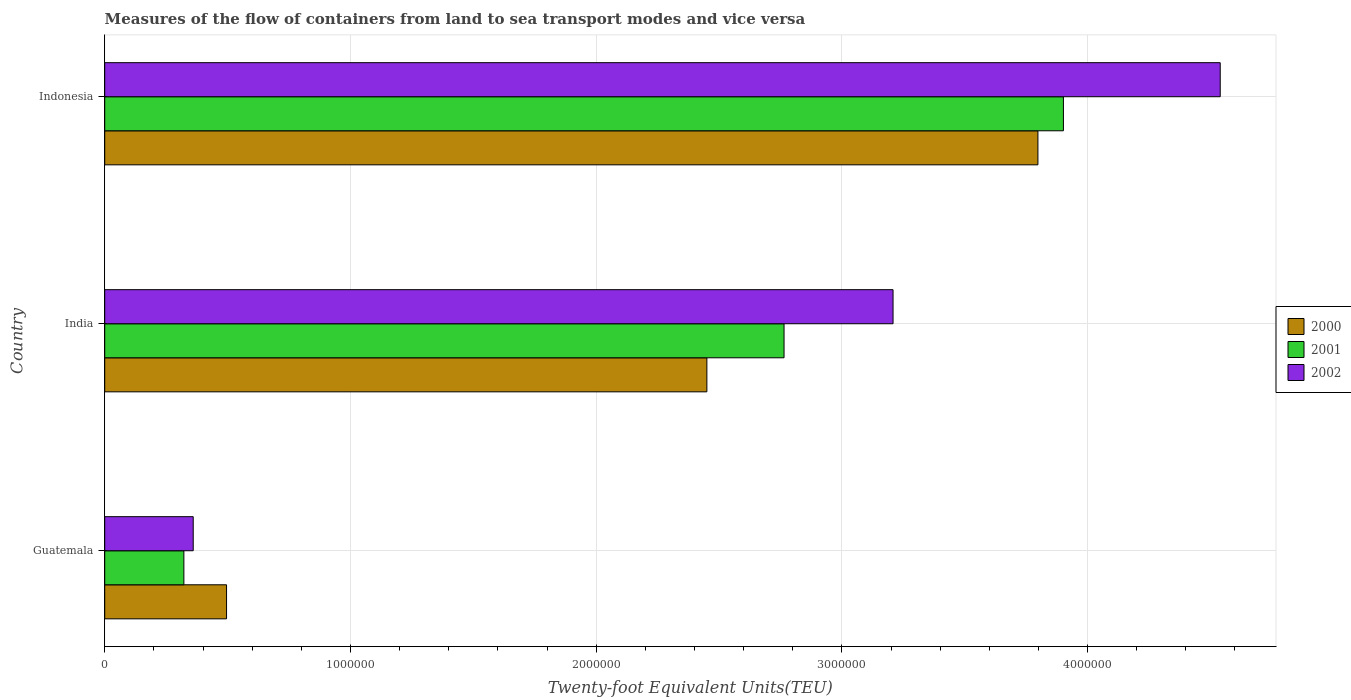Are the number of bars per tick equal to the number of legend labels?
Provide a succinct answer. Yes. Are the number of bars on each tick of the Y-axis equal?
Your answer should be very brief. Yes. How many bars are there on the 3rd tick from the bottom?
Provide a short and direct response. 3. What is the label of the 1st group of bars from the top?
Make the answer very short. Indonesia. What is the container port traffic in 2000 in India?
Your answer should be very brief. 2.45e+06. Across all countries, what is the maximum container port traffic in 2000?
Offer a very short reply. 3.80e+06. Across all countries, what is the minimum container port traffic in 2000?
Your answer should be very brief. 4.96e+05. In which country was the container port traffic in 2000 minimum?
Your response must be concise. Guatemala. What is the total container port traffic in 2001 in the graph?
Make the answer very short. 6.99e+06. What is the difference between the container port traffic in 2001 in India and that in Indonesia?
Provide a short and direct response. -1.14e+06. What is the difference between the container port traffic in 2001 in Guatemala and the container port traffic in 2000 in India?
Offer a very short reply. -2.13e+06. What is the average container port traffic in 2000 per country?
Offer a very short reply. 2.25e+06. What is the difference between the container port traffic in 2001 and container port traffic in 2000 in India?
Offer a very short reply. 3.14e+05. What is the ratio of the container port traffic in 2000 in Guatemala to that in Indonesia?
Your answer should be very brief. 0.13. Is the difference between the container port traffic in 2001 in India and Indonesia greater than the difference between the container port traffic in 2000 in India and Indonesia?
Offer a very short reply. Yes. What is the difference between the highest and the second highest container port traffic in 2002?
Your answer should be very brief. 1.33e+06. What is the difference between the highest and the lowest container port traffic in 2001?
Your response must be concise. 3.58e+06. In how many countries, is the container port traffic in 2000 greater than the average container port traffic in 2000 taken over all countries?
Offer a terse response. 2. Is the sum of the container port traffic in 2000 in India and Indonesia greater than the maximum container port traffic in 2001 across all countries?
Your answer should be compact. Yes. How many countries are there in the graph?
Keep it short and to the point. 3. What is the difference between two consecutive major ticks on the X-axis?
Ensure brevity in your answer.  1.00e+06. Are the values on the major ticks of X-axis written in scientific E-notation?
Keep it short and to the point. No. Does the graph contain any zero values?
Provide a short and direct response. No. Does the graph contain grids?
Your answer should be very brief. Yes. How are the legend labels stacked?
Your answer should be compact. Vertical. What is the title of the graph?
Offer a very short reply. Measures of the flow of containers from land to sea transport modes and vice versa. Does "1969" appear as one of the legend labels in the graph?
Give a very brief answer. No. What is the label or title of the X-axis?
Offer a very short reply. Twenty-foot Equivalent Units(TEU). What is the Twenty-foot Equivalent Units(TEU) of 2000 in Guatemala?
Keep it short and to the point. 4.96e+05. What is the Twenty-foot Equivalent Units(TEU) of 2001 in Guatemala?
Offer a very short reply. 3.22e+05. What is the Twenty-foot Equivalent Units(TEU) in 2002 in Guatemala?
Your response must be concise. 3.60e+05. What is the Twenty-foot Equivalent Units(TEU) of 2000 in India?
Make the answer very short. 2.45e+06. What is the Twenty-foot Equivalent Units(TEU) in 2001 in India?
Offer a very short reply. 2.76e+06. What is the Twenty-foot Equivalent Units(TEU) in 2002 in India?
Your answer should be compact. 3.21e+06. What is the Twenty-foot Equivalent Units(TEU) of 2000 in Indonesia?
Offer a terse response. 3.80e+06. What is the Twenty-foot Equivalent Units(TEU) in 2001 in Indonesia?
Give a very brief answer. 3.90e+06. What is the Twenty-foot Equivalent Units(TEU) of 2002 in Indonesia?
Provide a short and direct response. 4.54e+06. Across all countries, what is the maximum Twenty-foot Equivalent Units(TEU) of 2000?
Ensure brevity in your answer.  3.80e+06. Across all countries, what is the maximum Twenty-foot Equivalent Units(TEU) of 2001?
Offer a terse response. 3.90e+06. Across all countries, what is the maximum Twenty-foot Equivalent Units(TEU) of 2002?
Provide a succinct answer. 4.54e+06. Across all countries, what is the minimum Twenty-foot Equivalent Units(TEU) of 2000?
Your response must be concise. 4.96e+05. Across all countries, what is the minimum Twenty-foot Equivalent Units(TEU) in 2001?
Offer a very short reply. 3.22e+05. Across all countries, what is the minimum Twenty-foot Equivalent Units(TEU) of 2002?
Offer a terse response. 3.60e+05. What is the total Twenty-foot Equivalent Units(TEU) in 2000 in the graph?
Provide a succinct answer. 6.74e+06. What is the total Twenty-foot Equivalent Units(TEU) in 2001 in the graph?
Make the answer very short. 6.99e+06. What is the total Twenty-foot Equivalent Units(TEU) in 2002 in the graph?
Ensure brevity in your answer.  8.11e+06. What is the difference between the Twenty-foot Equivalent Units(TEU) in 2000 in Guatemala and that in India?
Keep it short and to the point. -1.95e+06. What is the difference between the Twenty-foot Equivalent Units(TEU) of 2001 in Guatemala and that in India?
Provide a succinct answer. -2.44e+06. What is the difference between the Twenty-foot Equivalent Units(TEU) of 2002 in Guatemala and that in India?
Provide a succinct answer. -2.85e+06. What is the difference between the Twenty-foot Equivalent Units(TEU) of 2000 in Guatemala and that in Indonesia?
Keep it short and to the point. -3.30e+06. What is the difference between the Twenty-foot Equivalent Units(TEU) in 2001 in Guatemala and that in Indonesia?
Make the answer very short. -3.58e+06. What is the difference between the Twenty-foot Equivalent Units(TEU) in 2002 in Guatemala and that in Indonesia?
Make the answer very short. -4.18e+06. What is the difference between the Twenty-foot Equivalent Units(TEU) of 2000 in India and that in Indonesia?
Keep it short and to the point. -1.35e+06. What is the difference between the Twenty-foot Equivalent Units(TEU) in 2001 in India and that in Indonesia?
Your response must be concise. -1.14e+06. What is the difference between the Twenty-foot Equivalent Units(TEU) in 2002 in India and that in Indonesia?
Your answer should be compact. -1.33e+06. What is the difference between the Twenty-foot Equivalent Units(TEU) in 2000 in Guatemala and the Twenty-foot Equivalent Units(TEU) in 2001 in India?
Your response must be concise. -2.27e+06. What is the difference between the Twenty-foot Equivalent Units(TEU) of 2000 in Guatemala and the Twenty-foot Equivalent Units(TEU) of 2002 in India?
Keep it short and to the point. -2.71e+06. What is the difference between the Twenty-foot Equivalent Units(TEU) of 2001 in Guatemala and the Twenty-foot Equivalent Units(TEU) of 2002 in India?
Ensure brevity in your answer.  -2.89e+06. What is the difference between the Twenty-foot Equivalent Units(TEU) in 2000 in Guatemala and the Twenty-foot Equivalent Units(TEU) in 2001 in Indonesia?
Offer a terse response. -3.41e+06. What is the difference between the Twenty-foot Equivalent Units(TEU) in 2000 in Guatemala and the Twenty-foot Equivalent Units(TEU) in 2002 in Indonesia?
Make the answer very short. -4.04e+06. What is the difference between the Twenty-foot Equivalent Units(TEU) of 2001 in Guatemala and the Twenty-foot Equivalent Units(TEU) of 2002 in Indonesia?
Ensure brevity in your answer.  -4.22e+06. What is the difference between the Twenty-foot Equivalent Units(TEU) in 2000 in India and the Twenty-foot Equivalent Units(TEU) in 2001 in Indonesia?
Provide a succinct answer. -1.45e+06. What is the difference between the Twenty-foot Equivalent Units(TEU) of 2000 in India and the Twenty-foot Equivalent Units(TEU) of 2002 in Indonesia?
Your response must be concise. -2.09e+06. What is the difference between the Twenty-foot Equivalent Units(TEU) of 2001 in India and the Twenty-foot Equivalent Units(TEU) of 2002 in Indonesia?
Your answer should be compact. -1.78e+06. What is the average Twenty-foot Equivalent Units(TEU) in 2000 per country?
Make the answer very short. 2.25e+06. What is the average Twenty-foot Equivalent Units(TEU) of 2001 per country?
Your answer should be compact. 2.33e+06. What is the average Twenty-foot Equivalent Units(TEU) of 2002 per country?
Your response must be concise. 2.70e+06. What is the difference between the Twenty-foot Equivalent Units(TEU) in 2000 and Twenty-foot Equivalent Units(TEU) in 2001 in Guatemala?
Offer a terse response. 1.74e+05. What is the difference between the Twenty-foot Equivalent Units(TEU) of 2000 and Twenty-foot Equivalent Units(TEU) of 2002 in Guatemala?
Make the answer very short. 1.36e+05. What is the difference between the Twenty-foot Equivalent Units(TEU) in 2001 and Twenty-foot Equivalent Units(TEU) in 2002 in Guatemala?
Provide a succinct answer. -3.80e+04. What is the difference between the Twenty-foot Equivalent Units(TEU) of 2000 and Twenty-foot Equivalent Units(TEU) of 2001 in India?
Ensure brevity in your answer.  -3.14e+05. What is the difference between the Twenty-foot Equivalent Units(TEU) of 2000 and Twenty-foot Equivalent Units(TEU) of 2002 in India?
Your response must be concise. -7.58e+05. What is the difference between the Twenty-foot Equivalent Units(TEU) of 2001 and Twenty-foot Equivalent Units(TEU) of 2002 in India?
Make the answer very short. -4.44e+05. What is the difference between the Twenty-foot Equivalent Units(TEU) in 2000 and Twenty-foot Equivalent Units(TEU) in 2001 in Indonesia?
Offer a terse response. -1.04e+05. What is the difference between the Twenty-foot Equivalent Units(TEU) of 2000 and Twenty-foot Equivalent Units(TEU) of 2002 in Indonesia?
Offer a very short reply. -7.42e+05. What is the difference between the Twenty-foot Equivalent Units(TEU) in 2001 and Twenty-foot Equivalent Units(TEU) in 2002 in Indonesia?
Make the answer very short. -6.38e+05. What is the ratio of the Twenty-foot Equivalent Units(TEU) of 2000 in Guatemala to that in India?
Your answer should be very brief. 0.2. What is the ratio of the Twenty-foot Equivalent Units(TEU) in 2001 in Guatemala to that in India?
Provide a short and direct response. 0.12. What is the ratio of the Twenty-foot Equivalent Units(TEU) in 2002 in Guatemala to that in India?
Make the answer very short. 0.11. What is the ratio of the Twenty-foot Equivalent Units(TEU) of 2000 in Guatemala to that in Indonesia?
Provide a succinct answer. 0.13. What is the ratio of the Twenty-foot Equivalent Units(TEU) of 2001 in Guatemala to that in Indonesia?
Keep it short and to the point. 0.08. What is the ratio of the Twenty-foot Equivalent Units(TEU) of 2002 in Guatemala to that in Indonesia?
Provide a short and direct response. 0.08. What is the ratio of the Twenty-foot Equivalent Units(TEU) of 2000 in India to that in Indonesia?
Your answer should be compact. 0.65. What is the ratio of the Twenty-foot Equivalent Units(TEU) in 2001 in India to that in Indonesia?
Your response must be concise. 0.71. What is the ratio of the Twenty-foot Equivalent Units(TEU) of 2002 in India to that in Indonesia?
Provide a short and direct response. 0.71. What is the difference between the highest and the second highest Twenty-foot Equivalent Units(TEU) in 2000?
Offer a very short reply. 1.35e+06. What is the difference between the highest and the second highest Twenty-foot Equivalent Units(TEU) of 2001?
Your answer should be very brief. 1.14e+06. What is the difference between the highest and the second highest Twenty-foot Equivalent Units(TEU) in 2002?
Your response must be concise. 1.33e+06. What is the difference between the highest and the lowest Twenty-foot Equivalent Units(TEU) in 2000?
Your answer should be very brief. 3.30e+06. What is the difference between the highest and the lowest Twenty-foot Equivalent Units(TEU) of 2001?
Make the answer very short. 3.58e+06. What is the difference between the highest and the lowest Twenty-foot Equivalent Units(TEU) of 2002?
Keep it short and to the point. 4.18e+06. 